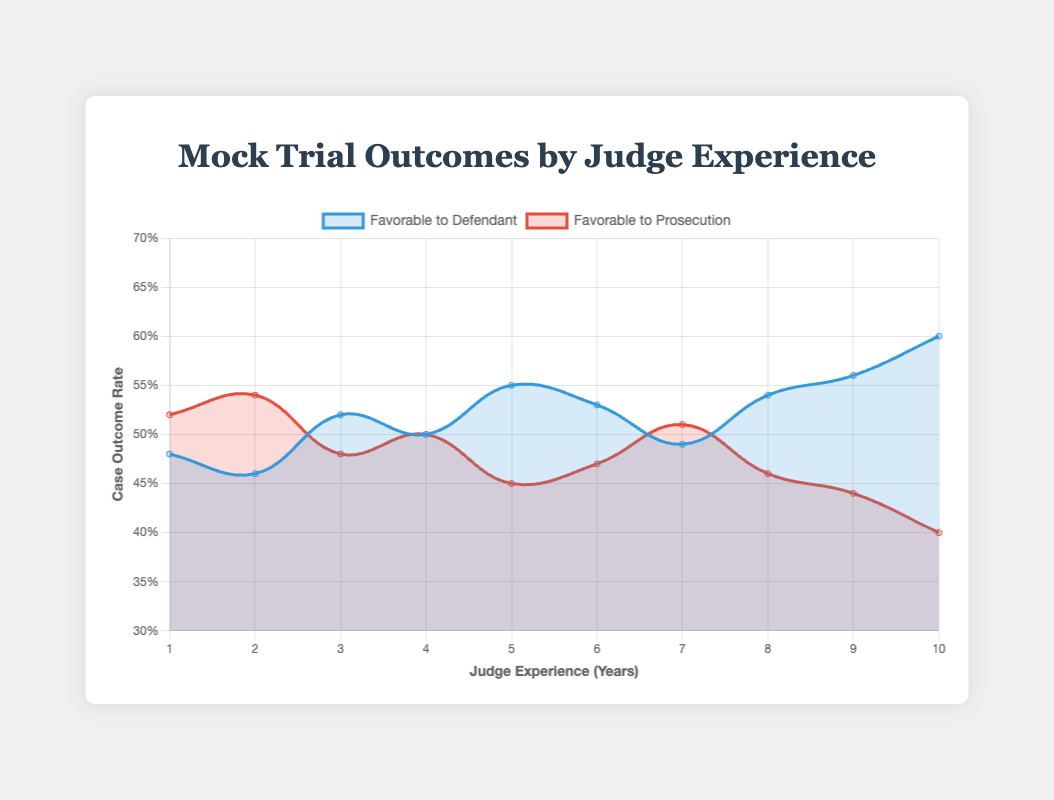What trend can you observe in the case outcomes favorable to the prosecution over the years? To observe the trend in case outcomes favorable to the prosecution, look at the red line in the plot. It starts at a rate of 52% favorable to the prosecution for judges with 1-year experience and generally declines over the 10 years, ending at a rate of 40%.
Answer: The trend shows a decrease in outcomes favorable to the prosecution How does the rate of outcomes favorable to the defendant change from year 1 to year 10? Observe the blue line in the plot. The rate starts at 48% for judges with 1-year experience and increases over the years, reaching 60% by year 10.
Answer: It increases from 48% to 60% What is the case outcome rate for both the defendant and the prosecution when the judge has 4 years of experience? Refer to the lines at the 4-year mark on the x-axis. Both the blue and red lines intersect at 50%. Therefore, the case outcome rate for both the defendant and the prosecution is 50%.
Answer: Both are 50% Which year shows the most favorable outcomes for the defendant? Look for the highest point on the blue line. The highest rate is 60%, occurring in year 10.
Answer: Year 10 By how much did the outcome rate favorable to the prosecution decrease between year 2 and year 6? Identify the points on the red line for years 2 and 6. The rate decreases from 54% in year 2 to 47% in year 6. Calculate the difference, which is 54% - 47% = 7%.
Answer: 7% How do the outcome trends for the defendant and the prosecution compare from year 6 to year 9? Compare the blue and red lines between years 6 and 9. The defendant's favorable outcomes increase from 53% to 56% while the prosecution's favorable outcomes decrease from 47% to 44%.
Answer: Defendant trends up, prosecution trends down What is the range of case outcome rates for the prosecution across the years of experience? Identify the highest and lowest points on the red line. The highest rate is 54% in year 2, and the lowest rate is 40% in year 10. The range is 54% - 40% = 14%.
Answer: 14% Are there any years where the case outcomes are equally favorable to both the defendant and the prosecution? Check the points where the blue and red lines intersect. They intersect at the 50% mark in year 4.
Answer: Year 4 Between years 5 and 6, how does the change in the rate for favorable defendant outcomes compare to the change in the rate for favorable prosecution outcomes? Look at the slopes of the blue and red lines between years 5 and 6. The blue line (defendant favorable rate) decreases from 55% to 53%. The red line (prosecution favorable rate) increases from 45% to 47%. The changes are equal and opposite by 2%.
Answer: Equal but opposite, both change by 2% What is the average case outcome rate favorable to the prosecution over the 10 years? Sum the prosecution favorable rates for each year and divide by the number of years: (52% + 54% + 48% + 50% + 45% + 47% + 51% + 46% + 44% + 40%) / 10 = 47.7%.
Answer: 47.7% 